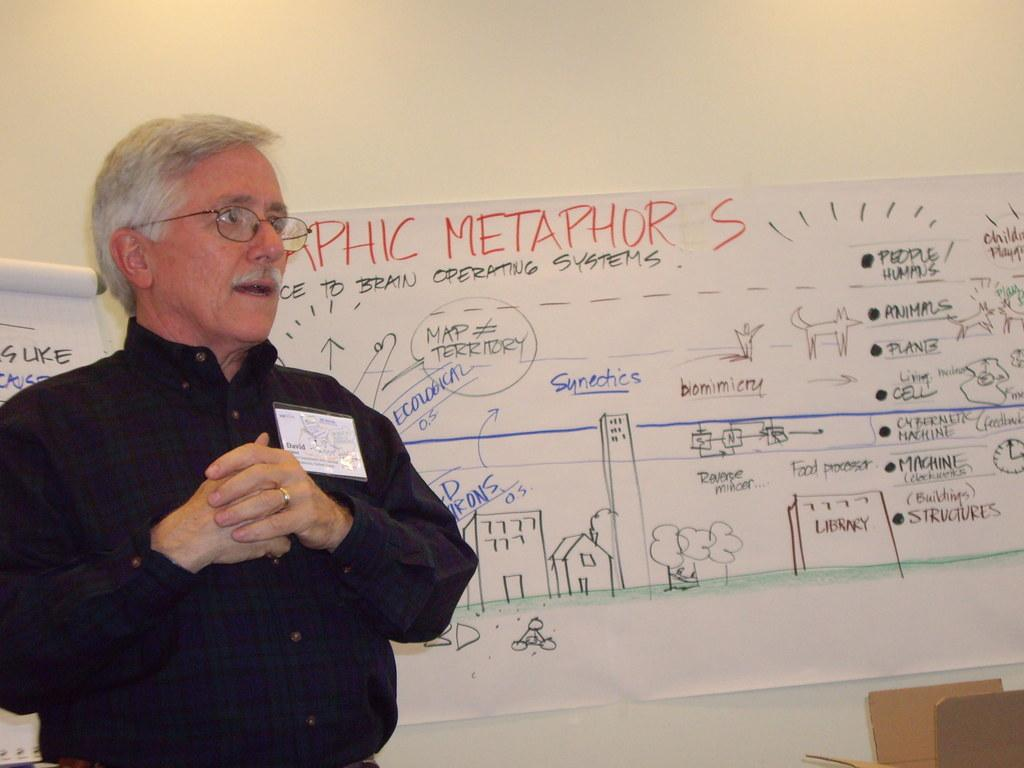Provide a one-sentence caption for the provided image. Graphic metaphors are explained by a man next to the sheet. 